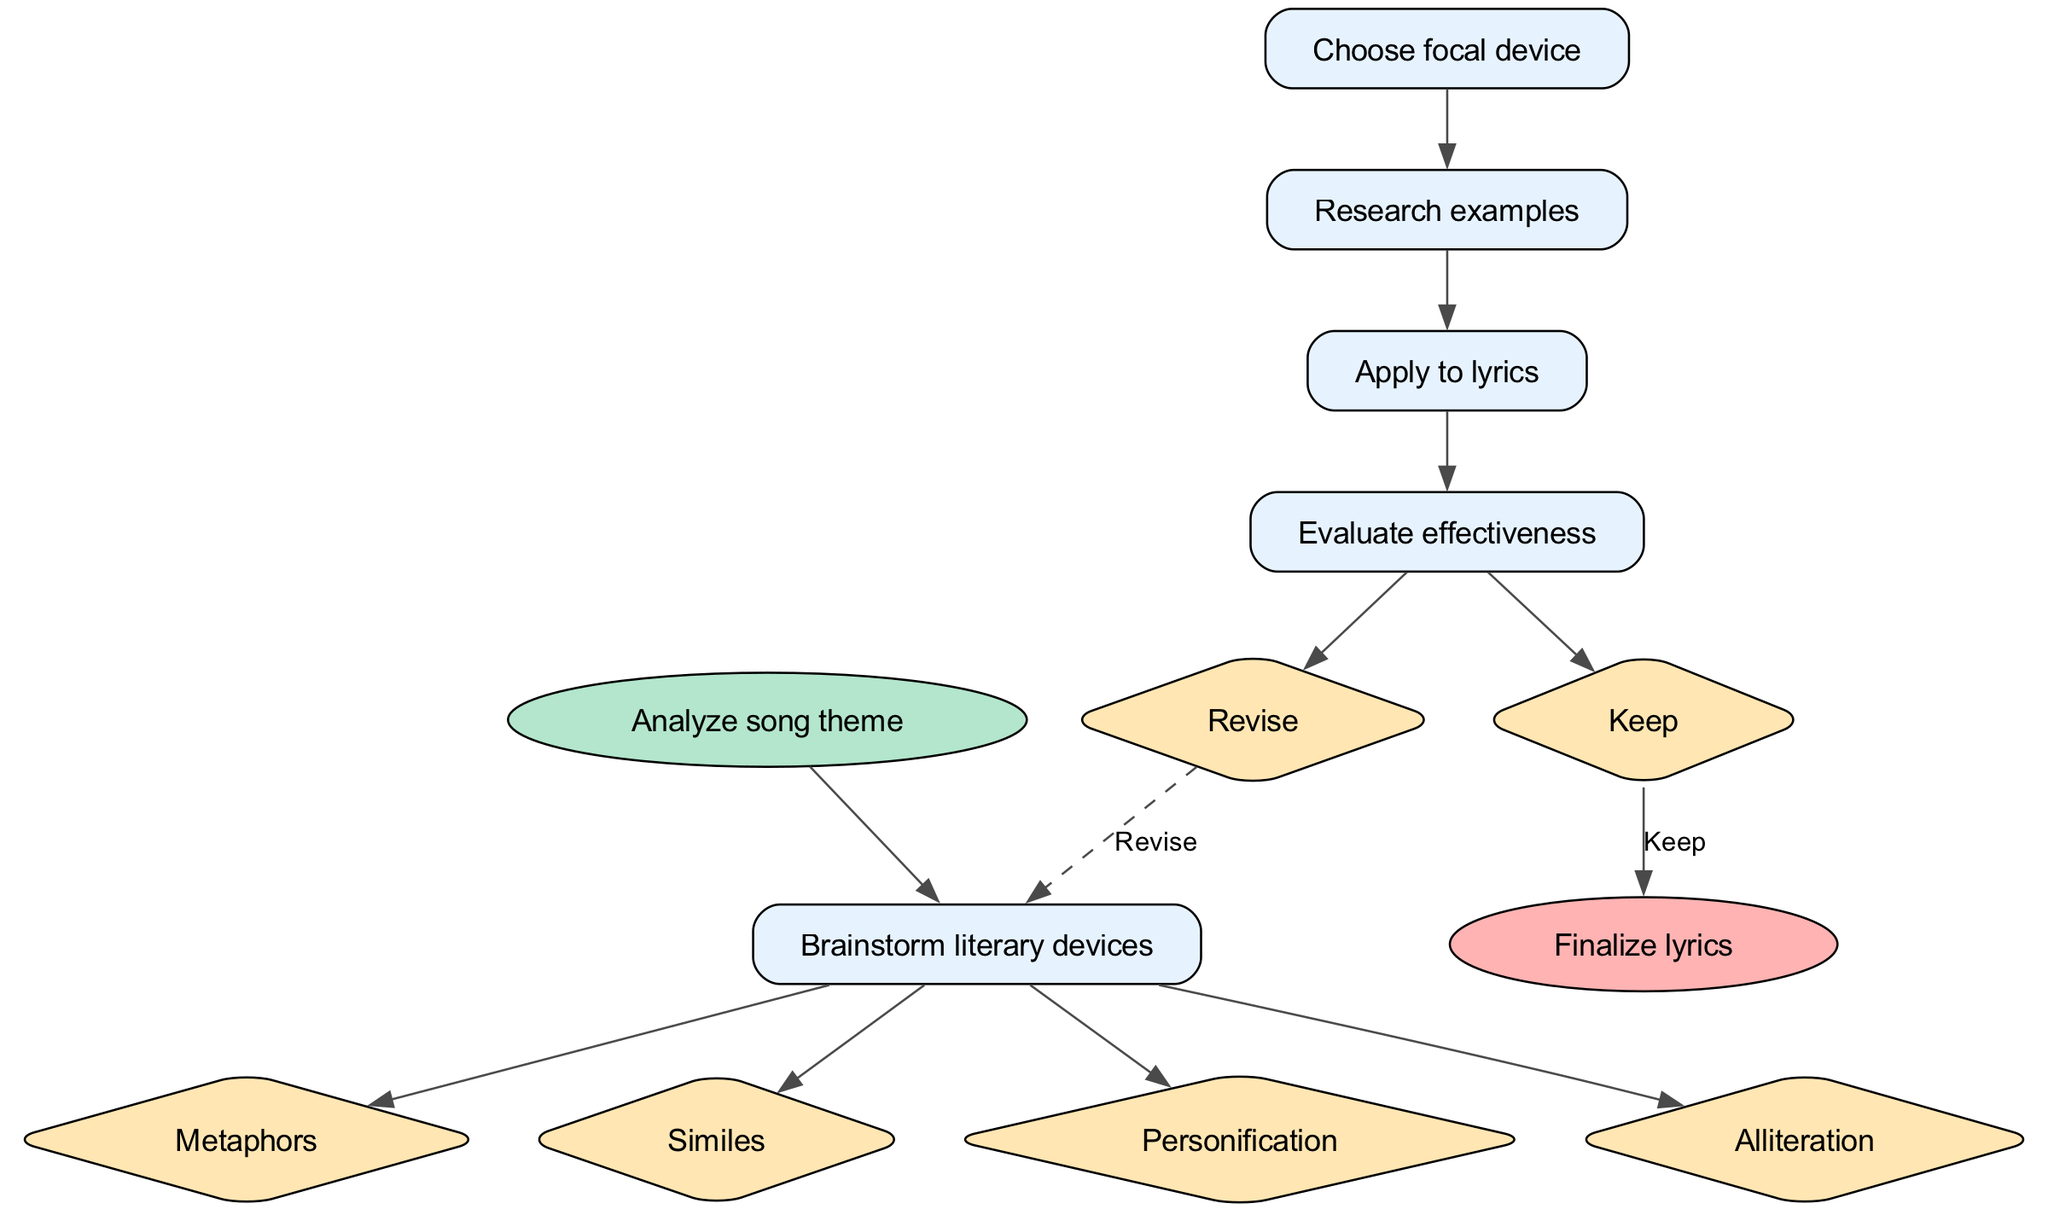What is the first step in the process? The first step is labeled as "Analyze song theme", which is indicated as the start node in the diagram.
Answer: Analyze song theme How many literary devices can be brainstormed? There are four literary devices listed: metaphors, similes, personification, and alliteration; each is represented as an option branching from the "Brainstorm literary devices" node.
Answer: Four What is the focal device decision based on? The focal device is chosen after brainstorming literary devices, as indicated on the flow from the "Brainstorm literary devices" node to the "Choose focal device" node.
Answer: Brainstormed options What follows after choosing the focal device? After choosing the focal device, the next step is to "Research examples", as shown in the sequence of steps in the diagram.
Answer: Research examples What happens if the effectiveness is "Keep"? If the effectiveness is labeled "Keep," the process proceeds directly to the end node "Finalize lyrics", as seen in the connection from the "Evaluate effectiveness" option to the end node.
Answer: Finalize lyrics How many options are available in the "Evaluate effectiveness" step? There are two options available: "Revise" and "Keep", which are represented as branching options from the "Evaluate effectiveness" node.
Answer: Two What nodes are connected to the "Apply to lyrics" step? The "Apply to lyrics" node connects from "Research examples" and leads to "Evaluate effectiveness", making it an intermediary step in the process.
Answer: Research examples and Evaluate effectiveness Which step involves applying learned information to lyrics? The step that involves applying learned information to lyrics is labeled "Apply to lyrics" and comes after "Research examples".
Answer: Apply to lyrics If a user revises the lyrics, where do they go next? If a user chooses to "Revise," they go back to the first step, which is "Brainstorm literary devices," indicated by a dashed edge returning to that step.
Answer: Brainstorm literary devices 